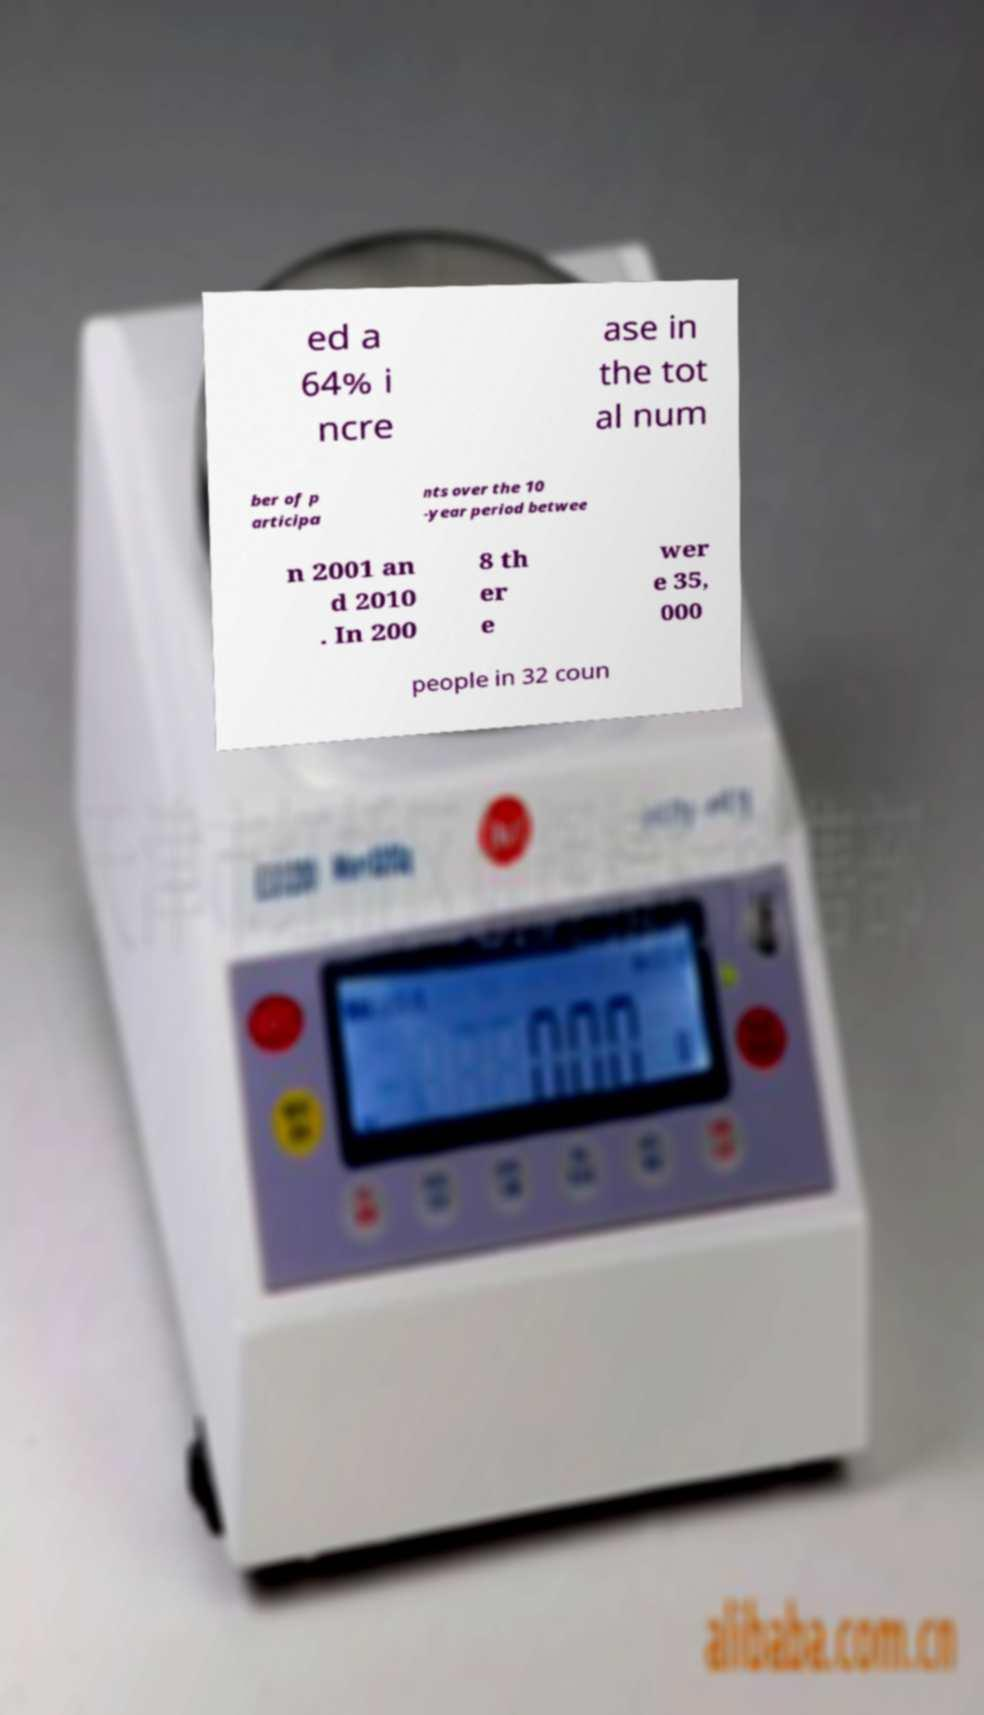Please identify and transcribe the text found in this image. ed a 64% i ncre ase in the tot al num ber of p articipa nts over the 10 -year period betwee n 2001 an d 2010 . In 200 8 th er e wer e 35, 000 people in 32 coun 